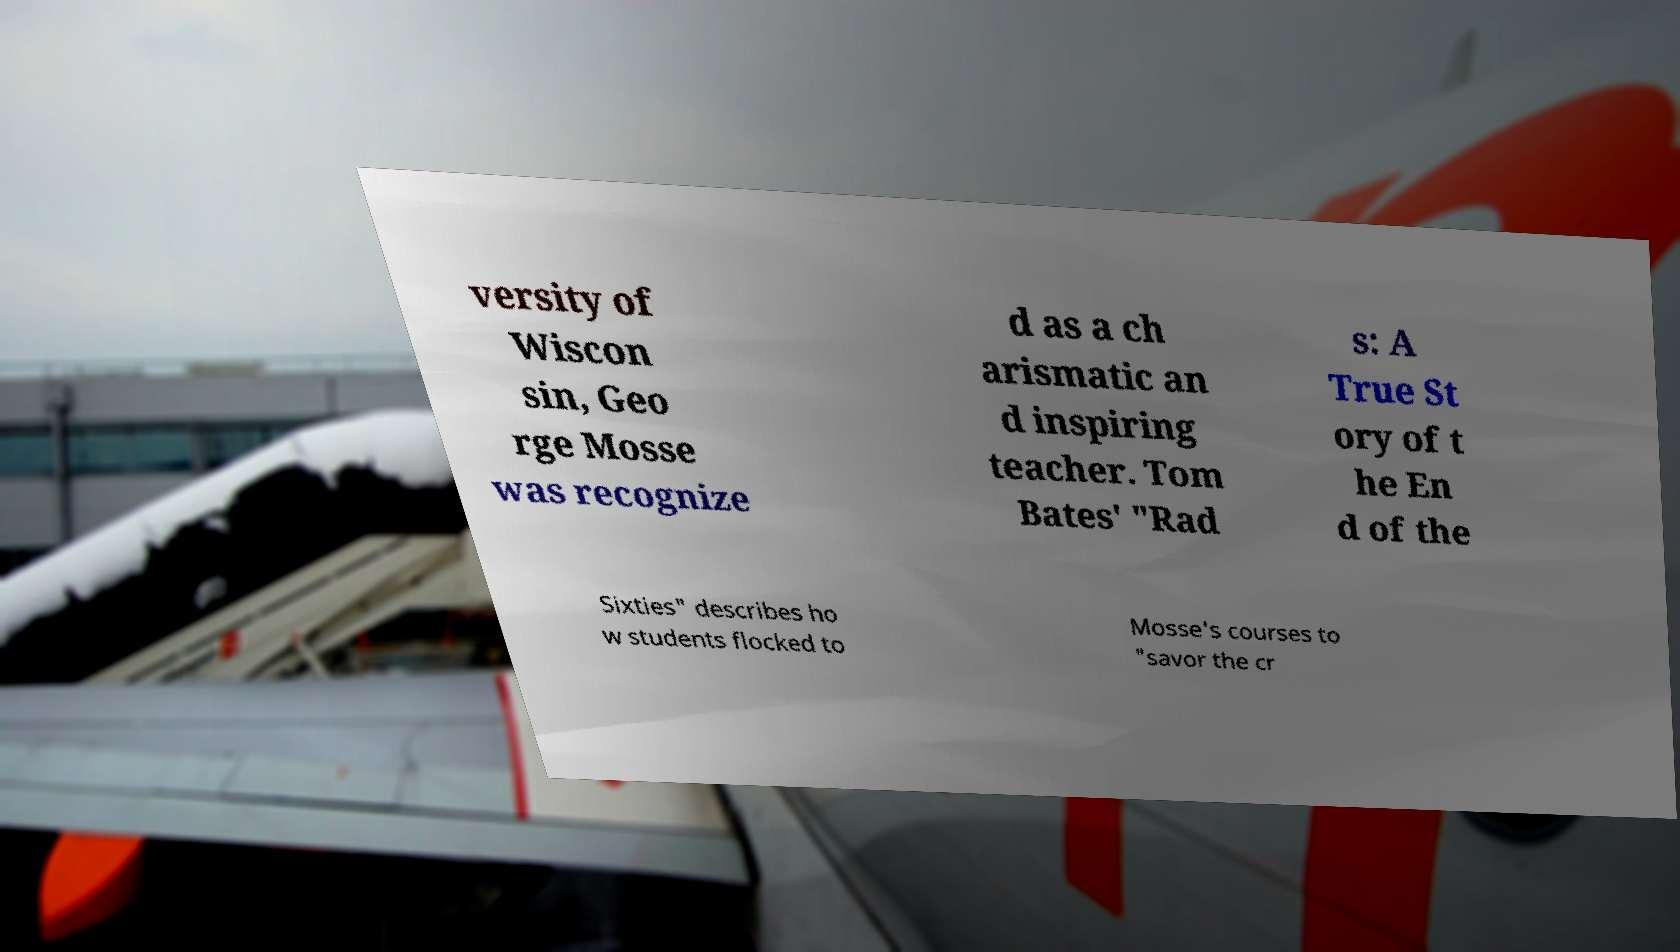Could you assist in decoding the text presented in this image and type it out clearly? versity of Wiscon sin, Geo rge Mosse was recognize d as a ch arismatic an d inspiring teacher. Tom Bates' "Rad s: A True St ory of t he En d of the Sixties" describes ho w students flocked to Mosse's courses to "savor the cr 